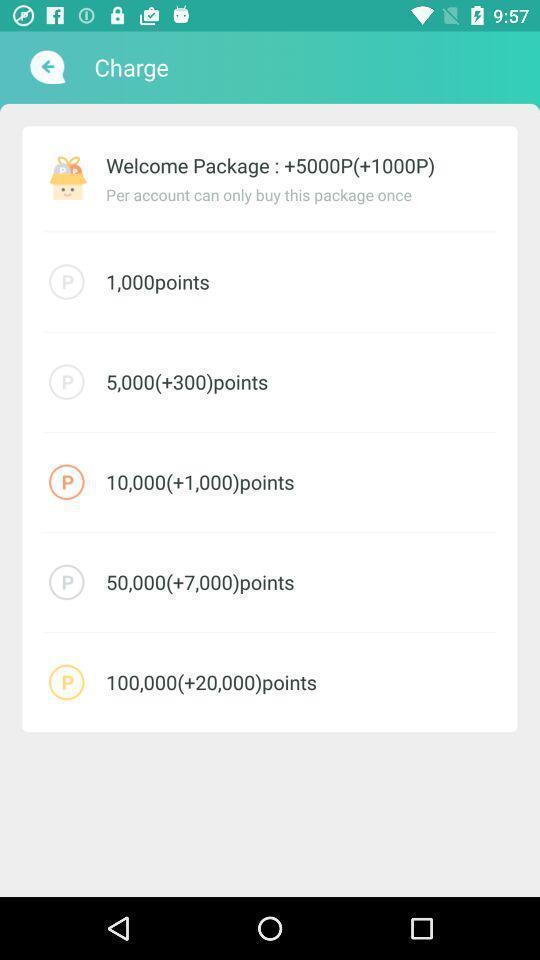Explain the elements present in this screenshot. Screen displaying the list of options. 